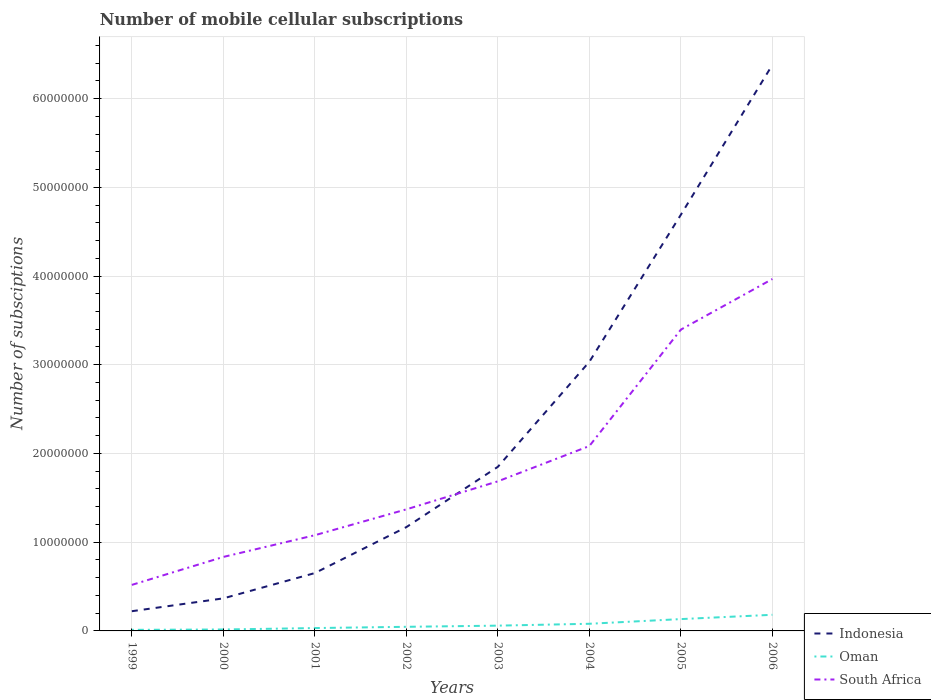Is the number of lines equal to the number of legend labels?
Your response must be concise. Yes. Across all years, what is the maximum number of mobile cellular subscriptions in South Africa?
Your answer should be compact. 5.19e+06. In which year was the number of mobile cellular subscriptions in South Africa maximum?
Keep it short and to the point. 1999. What is the total number of mobile cellular subscriptions in South Africa in the graph?
Provide a short and direct response. -2.28e+07. What is the difference between the highest and the second highest number of mobile cellular subscriptions in Indonesia?
Give a very brief answer. 6.16e+07. How many lines are there?
Provide a short and direct response. 3. How many years are there in the graph?
Make the answer very short. 8. Are the values on the major ticks of Y-axis written in scientific E-notation?
Offer a very short reply. No. Where does the legend appear in the graph?
Your response must be concise. Bottom right. How many legend labels are there?
Your answer should be compact. 3. How are the legend labels stacked?
Provide a succinct answer. Vertical. What is the title of the graph?
Offer a very short reply. Number of mobile cellular subscriptions. What is the label or title of the Y-axis?
Your answer should be compact. Number of subsciptions. What is the Number of subsciptions in Indonesia in 1999?
Your response must be concise. 2.22e+06. What is the Number of subsciptions of Oman in 1999?
Offer a terse response. 1.21e+05. What is the Number of subsciptions of South Africa in 1999?
Offer a very short reply. 5.19e+06. What is the Number of subsciptions of Indonesia in 2000?
Your answer should be compact. 3.67e+06. What is the Number of subsciptions of Oman in 2000?
Make the answer very short. 1.62e+05. What is the Number of subsciptions in South Africa in 2000?
Your response must be concise. 8.34e+06. What is the Number of subsciptions of Indonesia in 2001?
Your answer should be compact. 6.52e+06. What is the Number of subsciptions in Oman in 2001?
Offer a very short reply. 3.23e+05. What is the Number of subsciptions of South Africa in 2001?
Your response must be concise. 1.08e+07. What is the Number of subsciptions in Indonesia in 2002?
Keep it short and to the point. 1.17e+07. What is the Number of subsciptions in Oman in 2002?
Provide a short and direct response. 4.63e+05. What is the Number of subsciptions in South Africa in 2002?
Your answer should be very brief. 1.37e+07. What is the Number of subsciptions in Indonesia in 2003?
Your answer should be very brief. 1.85e+07. What is the Number of subsciptions of Oman in 2003?
Keep it short and to the point. 5.94e+05. What is the Number of subsciptions in South Africa in 2003?
Give a very brief answer. 1.69e+07. What is the Number of subsciptions in Indonesia in 2004?
Your answer should be very brief. 3.03e+07. What is the Number of subsciptions in Oman in 2004?
Provide a succinct answer. 8.06e+05. What is the Number of subsciptions of South Africa in 2004?
Make the answer very short. 2.08e+07. What is the Number of subsciptions in Indonesia in 2005?
Your response must be concise. 4.69e+07. What is the Number of subsciptions in Oman in 2005?
Ensure brevity in your answer.  1.33e+06. What is the Number of subsciptions in South Africa in 2005?
Provide a short and direct response. 3.40e+07. What is the Number of subsciptions of Indonesia in 2006?
Offer a very short reply. 6.38e+07. What is the Number of subsciptions of Oman in 2006?
Your answer should be compact. 1.82e+06. What is the Number of subsciptions of South Africa in 2006?
Your answer should be compact. 3.97e+07. Across all years, what is the maximum Number of subsciptions in Indonesia?
Provide a succinct answer. 6.38e+07. Across all years, what is the maximum Number of subsciptions in Oman?
Your response must be concise. 1.82e+06. Across all years, what is the maximum Number of subsciptions of South Africa?
Give a very brief answer. 3.97e+07. Across all years, what is the minimum Number of subsciptions of Indonesia?
Offer a terse response. 2.22e+06. Across all years, what is the minimum Number of subsciptions of Oman?
Your answer should be compact. 1.21e+05. Across all years, what is the minimum Number of subsciptions in South Africa?
Offer a terse response. 5.19e+06. What is the total Number of subsciptions in Indonesia in the graph?
Your answer should be compact. 1.84e+08. What is the total Number of subsciptions in Oman in the graph?
Make the answer very short. 5.62e+06. What is the total Number of subsciptions in South Africa in the graph?
Ensure brevity in your answer.  1.49e+08. What is the difference between the Number of subsciptions in Indonesia in 1999 and that in 2000?
Give a very brief answer. -1.45e+06. What is the difference between the Number of subsciptions in Oman in 1999 and that in 2000?
Offer a terse response. -4.10e+04. What is the difference between the Number of subsciptions of South Africa in 1999 and that in 2000?
Make the answer very short. -3.15e+06. What is the difference between the Number of subsciptions in Indonesia in 1999 and that in 2001?
Offer a very short reply. -4.30e+06. What is the difference between the Number of subsciptions of Oman in 1999 and that in 2001?
Provide a succinct answer. -2.02e+05. What is the difference between the Number of subsciptions of South Africa in 1999 and that in 2001?
Your answer should be very brief. -5.60e+06. What is the difference between the Number of subsciptions of Indonesia in 1999 and that in 2002?
Ensure brevity in your answer.  -9.48e+06. What is the difference between the Number of subsciptions of Oman in 1999 and that in 2002?
Offer a terse response. -3.42e+05. What is the difference between the Number of subsciptions in South Africa in 1999 and that in 2002?
Ensure brevity in your answer.  -8.51e+06. What is the difference between the Number of subsciptions in Indonesia in 1999 and that in 2003?
Your response must be concise. -1.63e+07. What is the difference between the Number of subsciptions in Oman in 1999 and that in 2003?
Your answer should be compact. -4.73e+05. What is the difference between the Number of subsciptions of South Africa in 1999 and that in 2003?
Keep it short and to the point. -1.17e+07. What is the difference between the Number of subsciptions of Indonesia in 1999 and that in 2004?
Your response must be concise. -2.81e+07. What is the difference between the Number of subsciptions of Oman in 1999 and that in 2004?
Your response must be concise. -6.85e+05. What is the difference between the Number of subsciptions in South Africa in 1999 and that in 2004?
Ensure brevity in your answer.  -1.57e+07. What is the difference between the Number of subsciptions of Indonesia in 1999 and that in 2005?
Your answer should be very brief. -4.47e+07. What is the difference between the Number of subsciptions of Oman in 1999 and that in 2005?
Ensure brevity in your answer.  -1.21e+06. What is the difference between the Number of subsciptions of South Africa in 1999 and that in 2005?
Provide a succinct answer. -2.88e+07. What is the difference between the Number of subsciptions of Indonesia in 1999 and that in 2006?
Make the answer very short. -6.16e+07. What is the difference between the Number of subsciptions in Oman in 1999 and that in 2006?
Your response must be concise. -1.70e+06. What is the difference between the Number of subsciptions in South Africa in 1999 and that in 2006?
Give a very brief answer. -3.45e+07. What is the difference between the Number of subsciptions in Indonesia in 2000 and that in 2001?
Your answer should be compact. -2.85e+06. What is the difference between the Number of subsciptions of Oman in 2000 and that in 2001?
Keep it short and to the point. -1.61e+05. What is the difference between the Number of subsciptions in South Africa in 2000 and that in 2001?
Your answer should be compact. -2.45e+06. What is the difference between the Number of subsciptions of Indonesia in 2000 and that in 2002?
Ensure brevity in your answer.  -8.03e+06. What is the difference between the Number of subsciptions in Oman in 2000 and that in 2002?
Make the answer very short. -3.01e+05. What is the difference between the Number of subsciptions in South Africa in 2000 and that in 2002?
Ensure brevity in your answer.  -5.36e+06. What is the difference between the Number of subsciptions of Indonesia in 2000 and that in 2003?
Keep it short and to the point. -1.48e+07. What is the difference between the Number of subsciptions in Oman in 2000 and that in 2003?
Offer a terse response. -4.32e+05. What is the difference between the Number of subsciptions in South Africa in 2000 and that in 2003?
Keep it short and to the point. -8.52e+06. What is the difference between the Number of subsciptions in Indonesia in 2000 and that in 2004?
Offer a very short reply. -2.67e+07. What is the difference between the Number of subsciptions in Oman in 2000 and that in 2004?
Give a very brief answer. -6.44e+05. What is the difference between the Number of subsciptions in South Africa in 2000 and that in 2004?
Ensure brevity in your answer.  -1.25e+07. What is the difference between the Number of subsciptions in Indonesia in 2000 and that in 2005?
Your answer should be compact. -4.32e+07. What is the difference between the Number of subsciptions in Oman in 2000 and that in 2005?
Ensure brevity in your answer.  -1.17e+06. What is the difference between the Number of subsciptions in South Africa in 2000 and that in 2005?
Ensure brevity in your answer.  -2.56e+07. What is the difference between the Number of subsciptions in Indonesia in 2000 and that in 2006?
Make the answer very short. -6.01e+07. What is the difference between the Number of subsciptions of Oman in 2000 and that in 2006?
Make the answer very short. -1.66e+06. What is the difference between the Number of subsciptions of South Africa in 2000 and that in 2006?
Ensure brevity in your answer.  -3.13e+07. What is the difference between the Number of subsciptions of Indonesia in 2001 and that in 2002?
Your answer should be compact. -5.18e+06. What is the difference between the Number of subsciptions in South Africa in 2001 and that in 2002?
Your response must be concise. -2.92e+06. What is the difference between the Number of subsciptions of Indonesia in 2001 and that in 2003?
Your answer should be compact. -1.20e+07. What is the difference between the Number of subsciptions of Oman in 2001 and that in 2003?
Ensure brevity in your answer.  -2.71e+05. What is the difference between the Number of subsciptions in South Africa in 2001 and that in 2003?
Offer a very short reply. -6.07e+06. What is the difference between the Number of subsciptions in Indonesia in 2001 and that in 2004?
Your answer should be very brief. -2.38e+07. What is the difference between the Number of subsciptions in Oman in 2001 and that in 2004?
Keep it short and to the point. -4.83e+05. What is the difference between the Number of subsciptions of South Africa in 2001 and that in 2004?
Your answer should be very brief. -1.01e+07. What is the difference between the Number of subsciptions in Indonesia in 2001 and that in 2005?
Keep it short and to the point. -4.04e+07. What is the difference between the Number of subsciptions of Oman in 2001 and that in 2005?
Make the answer very short. -1.01e+06. What is the difference between the Number of subsciptions in South Africa in 2001 and that in 2005?
Give a very brief answer. -2.32e+07. What is the difference between the Number of subsciptions in Indonesia in 2001 and that in 2006?
Your answer should be very brief. -5.73e+07. What is the difference between the Number of subsciptions of Oman in 2001 and that in 2006?
Keep it short and to the point. -1.50e+06. What is the difference between the Number of subsciptions of South Africa in 2001 and that in 2006?
Provide a short and direct response. -2.89e+07. What is the difference between the Number of subsciptions in Indonesia in 2002 and that in 2003?
Offer a very short reply. -6.80e+06. What is the difference between the Number of subsciptions in Oman in 2002 and that in 2003?
Your answer should be very brief. -1.31e+05. What is the difference between the Number of subsciptions of South Africa in 2002 and that in 2003?
Your response must be concise. -3.16e+06. What is the difference between the Number of subsciptions in Indonesia in 2002 and that in 2004?
Your response must be concise. -1.86e+07. What is the difference between the Number of subsciptions in Oman in 2002 and that in 2004?
Offer a very short reply. -3.43e+05. What is the difference between the Number of subsciptions of South Africa in 2002 and that in 2004?
Your answer should be very brief. -7.14e+06. What is the difference between the Number of subsciptions of Indonesia in 2002 and that in 2005?
Provide a succinct answer. -3.52e+07. What is the difference between the Number of subsciptions in Oman in 2002 and that in 2005?
Provide a short and direct response. -8.70e+05. What is the difference between the Number of subsciptions of South Africa in 2002 and that in 2005?
Your answer should be very brief. -2.03e+07. What is the difference between the Number of subsciptions in Indonesia in 2002 and that in 2006?
Ensure brevity in your answer.  -5.21e+07. What is the difference between the Number of subsciptions in Oman in 2002 and that in 2006?
Your response must be concise. -1.36e+06. What is the difference between the Number of subsciptions in South Africa in 2002 and that in 2006?
Offer a very short reply. -2.60e+07. What is the difference between the Number of subsciptions of Indonesia in 2003 and that in 2004?
Ensure brevity in your answer.  -1.18e+07. What is the difference between the Number of subsciptions in Oman in 2003 and that in 2004?
Your response must be concise. -2.12e+05. What is the difference between the Number of subsciptions in South Africa in 2003 and that in 2004?
Offer a very short reply. -3.98e+06. What is the difference between the Number of subsciptions in Indonesia in 2003 and that in 2005?
Your answer should be compact. -2.84e+07. What is the difference between the Number of subsciptions in Oman in 2003 and that in 2005?
Give a very brief answer. -7.39e+05. What is the difference between the Number of subsciptions in South Africa in 2003 and that in 2005?
Your answer should be compact. -1.71e+07. What is the difference between the Number of subsciptions in Indonesia in 2003 and that in 2006?
Offer a terse response. -4.53e+07. What is the difference between the Number of subsciptions in Oman in 2003 and that in 2006?
Your response must be concise. -1.22e+06. What is the difference between the Number of subsciptions in South Africa in 2003 and that in 2006?
Your answer should be very brief. -2.28e+07. What is the difference between the Number of subsciptions of Indonesia in 2004 and that in 2005?
Ensure brevity in your answer.  -1.66e+07. What is the difference between the Number of subsciptions of Oman in 2004 and that in 2005?
Provide a succinct answer. -5.27e+05. What is the difference between the Number of subsciptions of South Africa in 2004 and that in 2005?
Provide a short and direct response. -1.31e+07. What is the difference between the Number of subsciptions in Indonesia in 2004 and that in 2006?
Your response must be concise. -3.35e+07. What is the difference between the Number of subsciptions of Oman in 2004 and that in 2006?
Give a very brief answer. -1.01e+06. What is the difference between the Number of subsciptions of South Africa in 2004 and that in 2006?
Your response must be concise. -1.88e+07. What is the difference between the Number of subsciptions in Indonesia in 2005 and that in 2006?
Your answer should be compact. -1.69e+07. What is the difference between the Number of subsciptions in Oman in 2005 and that in 2006?
Provide a short and direct response. -4.85e+05. What is the difference between the Number of subsciptions in South Africa in 2005 and that in 2006?
Your response must be concise. -5.70e+06. What is the difference between the Number of subsciptions of Indonesia in 1999 and the Number of subsciptions of Oman in 2000?
Ensure brevity in your answer.  2.06e+06. What is the difference between the Number of subsciptions of Indonesia in 1999 and the Number of subsciptions of South Africa in 2000?
Make the answer very short. -6.12e+06. What is the difference between the Number of subsciptions of Oman in 1999 and the Number of subsciptions of South Africa in 2000?
Offer a very short reply. -8.22e+06. What is the difference between the Number of subsciptions of Indonesia in 1999 and the Number of subsciptions of Oman in 2001?
Ensure brevity in your answer.  1.90e+06. What is the difference between the Number of subsciptions in Indonesia in 1999 and the Number of subsciptions in South Africa in 2001?
Offer a terse response. -8.57e+06. What is the difference between the Number of subsciptions in Oman in 1999 and the Number of subsciptions in South Africa in 2001?
Offer a very short reply. -1.07e+07. What is the difference between the Number of subsciptions in Indonesia in 1999 and the Number of subsciptions in Oman in 2002?
Provide a succinct answer. 1.76e+06. What is the difference between the Number of subsciptions of Indonesia in 1999 and the Number of subsciptions of South Africa in 2002?
Keep it short and to the point. -1.15e+07. What is the difference between the Number of subsciptions of Oman in 1999 and the Number of subsciptions of South Africa in 2002?
Your answer should be very brief. -1.36e+07. What is the difference between the Number of subsciptions in Indonesia in 1999 and the Number of subsciptions in Oman in 2003?
Give a very brief answer. 1.63e+06. What is the difference between the Number of subsciptions in Indonesia in 1999 and the Number of subsciptions in South Africa in 2003?
Your answer should be compact. -1.46e+07. What is the difference between the Number of subsciptions in Oman in 1999 and the Number of subsciptions in South Africa in 2003?
Give a very brief answer. -1.67e+07. What is the difference between the Number of subsciptions of Indonesia in 1999 and the Number of subsciptions of Oman in 2004?
Provide a succinct answer. 1.41e+06. What is the difference between the Number of subsciptions of Indonesia in 1999 and the Number of subsciptions of South Africa in 2004?
Your response must be concise. -1.86e+07. What is the difference between the Number of subsciptions of Oman in 1999 and the Number of subsciptions of South Africa in 2004?
Provide a short and direct response. -2.07e+07. What is the difference between the Number of subsciptions of Indonesia in 1999 and the Number of subsciptions of Oman in 2005?
Offer a very short reply. 8.88e+05. What is the difference between the Number of subsciptions in Indonesia in 1999 and the Number of subsciptions in South Africa in 2005?
Give a very brief answer. -3.17e+07. What is the difference between the Number of subsciptions of Oman in 1999 and the Number of subsciptions of South Africa in 2005?
Offer a terse response. -3.38e+07. What is the difference between the Number of subsciptions in Indonesia in 1999 and the Number of subsciptions in Oman in 2006?
Your answer should be compact. 4.03e+05. What is the difference between the Number of subsciptions of Indonesia in 1999 and the Number of subsciptions of South Africa in 2006?
Provide a short and direct response. -3.74e+07. What is the difference between the Number of subsciptions in Oman in 1999 and the Number of subsciptions in South Africa in 2006?
Keep it short and to the point. -3.95e+07. What is the difference between the Number of subsciptions in Indonesia in 2000 and the Number of subsciptions in Oman in 2001?
Your answer should be very brief. 3.35e+06. What is the difference between the Number of subsciptions in Indonesia in 2000 and the Number of subsciptions in South Africa in 2001?
Give a very brief answer. -7.12e+06. What is the difference between the Number of subsciptions in Oman in 2000 and the Number of subsciptions in South Africa in 2001?
Offer a terse response. -1.06e+07. What is the difference between the Number of subsciptions of Indonesia in 2000 and the Number of subsciptions of Oman in 2002?
Provide a succinct answer. 3.21e+06. What is the difference between the Number of subsciptions in Indonesia in 2000 and the Number of subsciptions in South Africa in 2002?
Keep it short and to the point. -1.00e+07. What is the difference between the Number of subsciptions of Oman in 2000 and the Number of subsciptions of South Africa in 2002?
Offer a very short reply. -1.35e+07. What is the difference between the Number of subsciptions of Indonesia in 2000 and the Number of subsciptions of Oman in 2003?
Provide a short and direct response. 3.08e+06. What is the difference between the Number of subsciptions in Indonesia in 2000 and the Number of subsciptions in South Africa in 2003?
Keep it short and to the point. -1.32e+07. What is the difference between the Number of subsciptions of Oman in 2000 and the Number of subsciptions of South Africa in 2003?
Provide a succinct answer. -1.67e+07. What is the difference between the Number of subsciptions in Indonesia in 2000 and the Number of subsciptions in Oman in 2004?
Your response must be concise. 2.86e+06. What is the difference between the Number of subsciptions in Indonesia in 2000 and the Number of subsciptions in South Africa in 2004?
Ensure brevity in your answer.  -1.72e+07. What is the difference between the Number of subsciptions in Oman in 2000 and the Number of subsciptions in South Africa in 2004?
Give a very brief answer. -2.07e+07. What is the difference between the Number of subsciptions of Indonesia in 2000 and the Number of subsciptions of Oman in 2005?
Provide a succinct answer. 2.34e+06. What is the difference between the Number of subsciptions in Indonesia in 2000 and the Number of subsciptions in South Africa in 2005?
Provide a succinct answer. -3.03e+07. What is the difference between the Number of subsciptions in Oman in 2000 and the Number of subsciptions in South Africa in 2005?
Offer a terse response. -3.38e+07. What is the difference between the Number of subsciptions of Indonesia in 2000 and the Number of subsciptions of Oman in 2006?
Your response must be concise. 1.85e+06. What is the difference between the Number of subsciptions in Indonesia in 2000 and the Number of subsciptions in South Africa in 2006?
Offer a terse response. -3.60e+07. What is the difference between the Number of subsciptions of Oman in 2000 and the Number of subsciptions of South Africa in 2006?
Provide a succinct answer. -3.95e+07. What is the difference between the Number of subsciptions in Indonesia in 2001 and the Number of subsciptions in Oman in 2002?
Provide a succinct answer. 6.06e+06. What is the difference between the Number of subsciptions in Indonesia in 2001 and the Number of subsciptions in South Africa in 2002?
Ensure brevity in your answer.  -7.18e+06. What is the difference between the Number of subsciptions in Oman in 2001 and the Number of subsciptions in South Africa in 2002?
Provide a short and direct response. -1.34e+07. What is the difference between the Number of subsciptions in Indonesia in 2001 and the Number of subsciptions in Oman in 2003?
Provide a short and direct response. 5.93e+06. What is the difference between the Number of subsciptions in Indonesia in 2001 and the Number of subsciptions in South Africa in 2003?
Ensure brevity in your answer.  -1.03e+07. What is the difference between the Number of subsciptions in Oman in 2001 and the Number of subsciptions in South Africa in 2003?
Your answer should be very brief. -1.65e+07. What is the difference between the Number of subsciptions in Indonesia in 2001 and the Number of subsciptions in Oman in 2004?
Offer a terse response. 5.71e+06. What is the difference between the Number of subsciptions in Indonesia in 2001 and the Number of subsciptions in South Africa in 2004?
Give a very brief answer. -1.43e+07. What is the difference between the Number of subsciptions in Oman in 2001 and the Number of subsciptions in South Africa in 2004?
Your answer should be compact. -2.05e+07. What is the difference between the Number of subsciptions in Indonesia in 2001 and the Number of subsciptions in Oman in 2005?
Your answer should be very brief. 5.19e+06. What is the difference between the Number of subsciptions in Indonesia in 2001 and the Number of subsciptions in South Africa in 2005?
Your answer should be compact. -2.74e+07. What is the difference between the Number of subsciptions in Oman in 2001 and the Number of subsciptions in South Africa in 2005?
Your response must be concise. -3.36e+07. What is the difference between the Number of subsciptions in Indonesia in 2001 and the Number of subsciptions in Oman in 2006?
Ensure brevity in your answer.  4.70e+06. What is the difference between the Number of subsciptions in Indonesia in 2001 and the Number of subsciptions in South Africa in 2006?
Make the answer very short. -3.31e+07. What is the difference between the Number of subsciptions in Oman in 2001 and the Number of subsciptions in South Africa in 2006?
Provide a succinct answer. -3.93e+07. What is the difference between the Number of subsciptions of Indonesia in 2002 and the Number of subsciptions of Oman in 2003?
Ensure brevity in your answer.  1.11e+07. What is the difference between the Number of subsciptions of Indonesia in 2002 and the Number of subsciptions of South Africa in 2003?
Your answer should be compact. -5.16e+06. What is the difference between the Number of subsciptions in Oman in 2002 and the Number of subsciptions in South Africa in 2003?
Offer a very short reply. -1.64e+07. What is the difference between the Number of subsciptions in Indonesia in 2002 and the Number of subsciptions in Oman in 2004?
Keep it short and to the point. 1.09e+07. What is the difference between the Number of subsciptions in Indonesia in 2002 and the Number of subsciptions in South Africa in 2004?
Make the answer very short. -9.14e+06. What is the difference between the Number of subsciptions in Oman in 2002 and the Number of subsciptions in South Africa in 2004?
Ensure brevity in your answer.  -2.04e+07. What is the difference between the Number of subsciptions in Indonesia in 2002 and the Number of subsciptions in Oman in 2005?
Your answer should be very brief. 1.04e+07. What is the difference between the Number of subsciptions of Indonesia in 2002 and the Number of subsciptions of South Africa in 2005?
Your answer should be compact. -2.23e+07. What is the difference between the Number of subsciptions of Oman in 2002 and the Number of subsciptions of South Africa in 2005?
Give a very brief answer. -3.35e+07. What is the difference between the Number of subsciptions of Indonesia in 2002 and the Number of subsciptions of Oman in 2006?
Make the answer very short. 9.88e+06. What is the difference between the Number of subsciptions in Indonesia in 2002 and the Number of subsciptions in South Africa in 2006?
Your response must be concise. -2.80e+07. What is the difference between the Number of subsciptions in Oman in 2002 and the Number of subsciptions in South Africa in 2006?
Your answer should be compact. -3.92e+07. What is the difference between the Number of subsciptions in Indonesia in 2003 and the Number of subsciptions in Oman in 2004?
Provide a short and direct response. 1.77e+07. What is the difference between the Number of subsciptions of Indonesia in 2003 and the Number of subsciptions of South Africa in 2004?
Offer a terse response. -2.34e+06. What is the difference between the Number of subsciptions of Oman in 2003 and the Number of subsciptions of South Africa in 2004?
Your response must be concise. -2.02e+07. What is the difference between the Number of subsciptions of Indonesia in 2003 and the Number of subsciptions of Oman in 2005?
Ensure brevity in your answer.  1.72e+07. What is the difference between the Number of subsciptions in Indonesia in 2003 and the Number of subsciptions in South Africa in 2005?
Give a very brief answer. -1.55e+07. What is the difference between the Number of subsciptions in Oman in 2003 and the Number of subsciptions in South Africa in 2005?
Keep it short and to the point. -3.34e+07. What is the difference between the Number of subsciptions in Indonesia in 2003 and the Number of subsciptions in Oman in 2006?
Your answer should be compact. 1.67e+07. What is the difference between the Number of subsciptions of Indonesia in 2003 and the Number of subsciptions of South Africa in 2006?
Offer a very short reply. -2.12e+07. What is the difference between the Number of subsciptions in Oman in 2003 and the Number of subsciptions in South Africa in 2006?
Provide a succinct answer. -3.91e+07. What is the difference between the Number of subsciptions of Indonesia in 2004 and the Number of subsciptions of Oman in 2005?
Offer a terse response. 2.90e+07. What is the difference between the Number of subsciptions of Indonesia in 2004 and the Number of subsciptions of South Africa in 2005?
Your answer should be very brief. -3.62e+06. What is the difference between the Number of subsciptions in Oman in 2004 and the Number of subsciptions in South Africa in 2005?
Your answer should be compact. -3.32e+07. What is the difference between the Number of subsciptions of Indonesia in 2004 and the Number of subsciptions of Oman in 2006?
Give a very brief answer. 2.85e+07. What is the difference between the Number of subsciptions in Indonesia in 2004 and the Number of subsciptions in South Africa in 2006?
Provide a succinct answer. -9.33e+06. What is the difference between the Number of subsciptions in Oman in 2004 and the Number of subsciptions in South Africa in 2006?
Ensure brevity in your answer.  -3.89e+07. What is the difference between the Number of subsciptions in Indonesia in 2005 and the Number of subsciptions in Oman in 2006?
Your answer should be compact. 4.51e+07. What is the difference between the Number of subsciptions in Indonesia in 2005 and the Number of subsciptions in South Africa in 2006?
Make the answer very short. 7.25e+06. What is the difference between the Number of subsciptions of Oman in 2005 and the Number of subsciptions of South Africa in 2006?
Offer a terse response. -3.83e+07. What is the average Number of subsciptions in Indonesia per year?
Your answer should be very brief. 2.30e+07. What is the average Number of subsciptions in Oman per year?
Keep it short and to the point. 7.03e+05. What is the average Number of subsciptions of South Africa per year?
Ensure brevity in your answer.  1.87e+07. In the year 1999, what is the difference between the Number of subsciptions of Indonesia and Number of subsciptions of Oman?
Provide a short and direct response. 2.10e+06. In the year 1999, what is the difference between the Number of subsciptions in Indonesia and Number of subsciptions in South Africa?
Make the answer very short. -2.97e+06. In the year 1999, what is the difference between the Number of subsciptions in Oman and Number of subsciptions in South Africa?
Your answer should be compact. -5.07e+06. In the year 2000, what is the difference between the Number of subsciptions in Indonesia and Number of subsciptions in Oman?
Your answer should be compact. 3.51e+06. In the year 2000, what is the difference between the Number of subsciptions of Indonesia and Number of subsciptions of South Africa?
Give a very brief answer. -4.67e+06. In the year 2000, what is the difference between the Number of subsciptions of Oman and Number of subsciptions of South Africa?
Offer a terse response. -8.18e+06. In the year 2001, what is the difference between the Number of subsciptions in Indonesia and Number of subsciptions in Oman?
Offer a terse response. 6.20e+06. In the year 2001, what is the difference between the Number of subsciptions of Indonesia and Number of subsciptions of South Africa?
Give a very brief answer. -4.27e+06. In the year 2001, what is the difference between the Number of subsciptions in Oman and Number of subsciptions in South Africa?
Offer a very short reply. -1.05e+07. In the year 2002, what is the difference between the Number of subsciptions in Indonesia and Number of subsciptions in Oman?
Make the answer very short. 1.12e+07. In the year 2002, what is the difference between the Number of subsciptions in Indonesia and Number of subsciptions in South Africa?
Give a very brief answer. -2.00e+06. In the year 2002, what is the difference between the Number of subsciptions in Oman and Number of subsciptions in South Africa?
Provide a succinct answer. -1.32e+07. In the year 2003, what is the difference between the Number of subsciptions of Indonesia and Number of subsciptions of Oman?
Give a very brief answer. 1.79e+07. In the year 2003, what is the difference between the Number of subsciptions of Indonesia and Number of subsciptions of South Africa?
Make the answer very short. 1.64e+06. In the year 2003, what is the difference between the Number of subsciptions of Oman and Number of subsciptions of South Africa?
Provide a succinct answer. -1.63e+07. In the year 2004, what is the difference between the Number of subsciptions in Indonesia and Number of subsciptions in Oman?
Offer a terse response. 2.95e+07. In the year 2004, what is the difference between the Number of subsciptions in Indonesia and Number of subsciptions in South Africa?
Make the answer very short. 9.50e+06. In the year 2004, what is the difference between the Number of subsciptions in Oman and Number of subsciptions in South Africa?
Your answer should be very brief. -2.00e+07. In the year 2005, what is the difference between the Number of subsciptions of Indonesia and Number of subsciptions of Oman?
Your answer should be very brief. 4.56e+07. In the year 2005, what is the difference between the Number of subsciptions of Indonesia and Number of subsciptions of South Africa?
Provide a succinct answer. 1.30e+07. In the year 2005, what is the difference between the Number of subsciptions in Oman and Number of subsciptions in South Africa?
Your response must be concise. -3.26e+07. In the year 2006, what is the difference between the Number of subsciptions of Indonesia and Number of subsciptions of Oman?
Your answer should be very brief. 6.20e+07. In the year 2006, what is the difference between the Number of subsciptions of Indonesia and Number of subsciptions of South Africa?
Your answer should be very brief. 2.41e+07. In the year 2006, what is the difference between the Number of subsciptions in Oman and Number of subsciptions in South Africa?
Make the answer very short. -3.78e+07. What is the ratio of the Number of subsciptions of Indonesia in 1999 to that in 2000?
Ensure brevity in your answer.  0.61. What is the ratio of the Number of subsciptions of Oman in 1999 to that in 2000?
Make the answer very short. 0.75. What is the ratio of the Number of subsciptions of South Africa in 1999 to that in 2000?
Keep it short and to the point. 0.62. What is the ratio of the Number of subsciptions in Indonesia in 1999 to that in 2001?
Your answer should be very brief. 0.34. What is the ratio of the Number of subsciptions of Oman in 1999 to that in 2001?
Your answer should be compact. 0.37. What is the ratio of the Number of subsciptions in South Africa in 1999 to that in 2001?
Make the answer very short. 0.48. What is the ratio of the Number of subsciptions in Indonesia in 1999 to that in 2002?
Keep it short and to the point. 0.19. What is the ratio of the Number of subsciptions in Oman in 1999 to that in 2002?
Make the answer very short. 0.26. What is the ratio of the Number of subsciptions in South Africa in 1999 to that in 2002?
Your answer should be very brief. 0.38. What is the ratio of the Number of subsciptions in Indonesia in 1999 to that in 2003?
Your answer should be very brief. 0.12. What is the ratio of the Number of subsciptions in Oman in 1999 to that in 2003?
Your answer should be compact. 0.2. What is the ratio of the Number of subsciptions of South Africa in 1999 to that in 2003?
Your answer should be very brief. 0.31. What is the ratio of the Number of subsciptions in Indonesia in 1999 to that in 2004?
Ensure brevity in your answer.  0.07. What is the ratio of the Number of subsciptions of Oman in 1999 to that in 2004?
Ensure brevity in your answer.  0.15. What is the ratio of the Number of subsciptions of South Africa in 1999 to that in 2004?
Ensure brevity in your answer.  0.25. What is the ratio of the Number of subsciptions of Indonesia in 1999 to that in 2005?
Offer a very short reply. 0.05. What is the ratio of the Number of subsciptions of Oman in 1999 to that in 2005?
Provide a short and direct response. 0.09. What is the ratio of the Number of subsciptions of South Africa in 1999 to that in 2005?
Your response must be concise. 0.15. What is the ratio of the Number of subsciptions in Indonesia in 1999 to that in 2006?
Offer a very short reply. 0.03. What is the ratio of the Number of subsciptions of Oman in 1999 to that in 2006?
Your answer should be compact. 0.07. What is the ratio of the Number of subsciptions of South Africa in 1999 to that in 2006?
Keep it short and to the point. 0.13. What is the ratio of the Number of subsciptions of Indonesia in 2000 to that in 2001?
Your answer should be very brief. 0.56. What is the ratio of the Number of subsciptions of Oman in 2000 to that in 2001?
Offer a terse response. 0.5. What is the ratio of the Number of subsciptions of South Africa in 2000 to that in 2001?
Give a very brief answer. 0.77. What is the ratio of the Number of subsciptions of Indonesia in 2000 to that in 2002?
Provide a short and direct response. 0.31. What is the ratio of the Number of subsciptions in Oman in 2000 to that in 2002?
Ensure brevity in your answer.  0.35. What is the ratio of the Number of subsciptions of South Africa in 2000 to that in 2002?
Offer a very short reply. 0.61. What is the ratio of the Number of subsciptions in Indonesia in 2000 to that in 2003?
Make the answer very short. 0.2. What is the ratio of the Number of subsciptions in Oman in 2000 to that in 2003?
Make the answer very short. 0.27. What is the ratio of the Number of subsciptions in South Africa in 2000 to that in 2003?
Give a very brief answer. 0.49. What is the ratio of the Number of subsciptions in Indonesia in 2000 to that in 2004?
Provide a succinct answer. 0.12. What is the ratio of the Number of subsciptions of Oman in 2000 to that in 2004?
Provide a short and direct response. 0.2. What is the ratio of the Number of subsciptions in South Africa in 2000 to that in 2004?
Provide a succinct answer. 0.4. What is the ratio of the Number of subsciptions of Indonesia in 2000 to that in 2005?
Your answer should be compact. 0.08. What is the ratio of the Number of subsciptions of Oman in 2000 to that in 2005?
Offer a very short reply. 0.12. What is the ratio of the Number of subsciptions of South Africa in 2000 to that in 2005?
Provide a succinct answer. 0.25. What is the ratio of the Number of subsciptions of Indonesia in 2000 to that in 2006?
Offer a terse response. 0.06. What is the ratio of the Number of subsciptions of Oman in 2000 to that in 2006?
Give a very brief answer. 0.09. What is the ratio of the Number of subsciptions of South Africa in 2000 to that in 2006?
Ensure brevity in your answer.  0.21. What is the ratio of the Number of subsciptions of Indonesia in 2001 to that in 2002?
Your response must be concise. 0.56. What is the ratio of the Number of subsciptions in Oman in 2001 to that in 2002?
Your response must be concise. 0.7. What is the ratio of the Number of subsciptions of South Africa in 2001 to that in 2002?
Offer a very short reply. 0.79. What is the ratio of the Number of subsciptions of Indonesia in 2001 to that in 2003?
Your response must be concise. 0.35. What is the ratio of the Number of subsciptions of Oman in 2001 to that in 2003?
Give a very brief answer. 0.54. What is the ratio of the Number of subsciptions of South Africa in 2001 to that in 2003?
Offer a terse response. 0.64. What is the ratio of the Number of subsciptions of Indonesia in 2001 to that in 2004?
Offer a very short reply. 0.21. What is the ratio of the Number of subsciptions of Oman in 2001 to that in 2004?
Provide a short and direct response. 0.4. What is the ratio of the Number of subsciptions in South Africa in 2001 to that in 2004?
Offer a very short reply. 0.52. What is the ratio of the Number of subsciptions of Indonesia in 2001 to that in 2005?
Your answer should be very brief. 0.14. What is the ratio of the Number of subsciptions of Oman in 2001 to that in 2005?
Your answer should be very brief. 0.24. What is the ratio of the Number of subsciptions in South Africa in 2001 to that in 2005?
Provide a short and direct response. 0.32. What is the ratio of the Number of subsciptions in Indonesia in 2001 to that in 2006?
Make the answer very short. 0.1. What is the ratio of the Number of subsciptions of Oman in 2001 to that in 2006?
Offer a very short reply. 0.18. What is the ratio of the Number of subsciptions in South Africa in 2001 to that in 2006?
Provide a succinct answer. 0.27. What is the ratio of the Number of subsciptions of Indonesia in 2002 to that in 2003?
Provide a short and direct response. 0.63. What is the ratio of the Number of subsciptions of Oman in 2002 to that in 2003?
Provide a succinct answer. 0.78. What is the ratio of the Number of subsciptions of South Africa in 2002 to that in 2003?
Give a very brief answer. 0.81. What is the ratio of the Number of subsciptions in Indonesia in 2002 to that in 2004?
Offer a terse response. 0.39. What is the ratio of the Number of subsciptions in Oman in 2002 to that in 2004?
Your answer should be very brief. 0.57. What is the ratio of the Number of subsciptions of South Africa in 2002 to that in 2004?
Your answer should be very brief. 0.66. What is the ratio of the Number of subsciptions in Indonesia in 2002 to that in 2005?
Your response must be concise. 0.25. What is the ratio of the Number of subsciptions of Oman in 2002 to that in 2005?
Offer a very short reply. 0.35. What is the ratio of the Number of subsciptions of South Africa in 2002 to that in 2005?
Offer a terse response. 0.4. What is the ratio of the Number of subsciptions in Indonesia in 2002 to that in 2006?
Your answer should be very brief. 0.18. What is the ratio of the Number of subsciptions of Oman in 2002 to that in 2006?
Your answer should be compact. 0.25. What is the ratio of the Number of subsciptions of South Africa in 2002 to that in 2006?
Offer a very short reply. 0.35. What is the ratio of the Number of subsciptions in Indonesia in 2003 to that in 2004?
Your answer should be very brief. 0.61. What is the ratio of the Number of subsciptions in Oman in 2003 to that in 2004?
Your answer should be compact. 0.74. What is the ratio of the Number of subsciptions in South Africa in 2003 to that in 2004?
Your answer should be very brief. 0.81. What is the ratio of the Number of subsciptions of Indonesia in 2003 to that in 2005?
Provide a succinct answer. 0.39. What is the ratio of the Number of subsciptions in Oman in 2003 to that in 2005?
Offer a very short reply. 0.45. What is the ratio of the Number of subsciptions in South Africa in 2003 to that in 2005?
Make the answer very short. 0.5. What is the ratio of the Number of subsciptions in Indonesia in 2003 to that in 2006?
Give a very brief answer. 0.29. What is the ratio of the Number of subsciptions in Oman in 2003 to that in 2006?
Keep it short and to the point. 0.33. What is the ratio of the Number of subsciptions of South Africa in 2003 to that in 2006?
Give a very brief answer. 0.43. What is the ratio of the Number of subsciptions of Indonesia in 2004 to that in 2005?
Your response must be concise. 0.65. What is the ratio of the Number of subsciptions of Oman in 2004 to that in 2005?
Provide a short and direct response. 0.6. What is the ratio of the Number of subsciptions of South Africa in 2004 to that in 2005?
Ensure brevity in your answer.  0.61. What is the ratio of the Number of subsciptions of Indonesia in 2004 to that in 2006?
Your answer should be very brief. 0.48. What is the ratio of the Number of subsciptions of Oman in 2004 to that in 2006?
Offer a very short reply. 0.44. What is the ratio of the Number of subsciptions in South Africa in 2004 to that in 2006?
Ensure brevity in your answer.  0.53. What is the ratio of the Number of subsciptions of Indonesia in 2005 to that in 2006?
Make the answer very short. 0.74. What is the ratio of the Number of subsciptions of Oman in 2005 to that in 2006?
Ensure brevity in your answer.  0.73. What is the ratio of the Number of subsciptions of South Africa in 2005 to that in 2006?
Provide a short and direct response. 0.86. What is the difference between the highest and the second highest Number of subsciptions of Indonesia?
Your response must be concise. 1.69e+07. What is the difference between the highest and the second highest Number of subsciptions of Oman?
Make the answer very short. 4.85e+05. What is the difference between the highest and the second highest Number of subsciptions of South Africa?
Your response must be concise. 5.70e+06. What is the difference between the highest and the lowest Number of subsciptions of Indonesia?
Provide a short and direct response. 6.16e+07. What is the difference between the highest and the lowest Number of subsciptions of Oman?
Offer a very short reply. 1.70e+06. What is the difference between the highest and the lowest Number of subsciptions of South Africa?
Keep it short and to the point. 3.45e+07. 